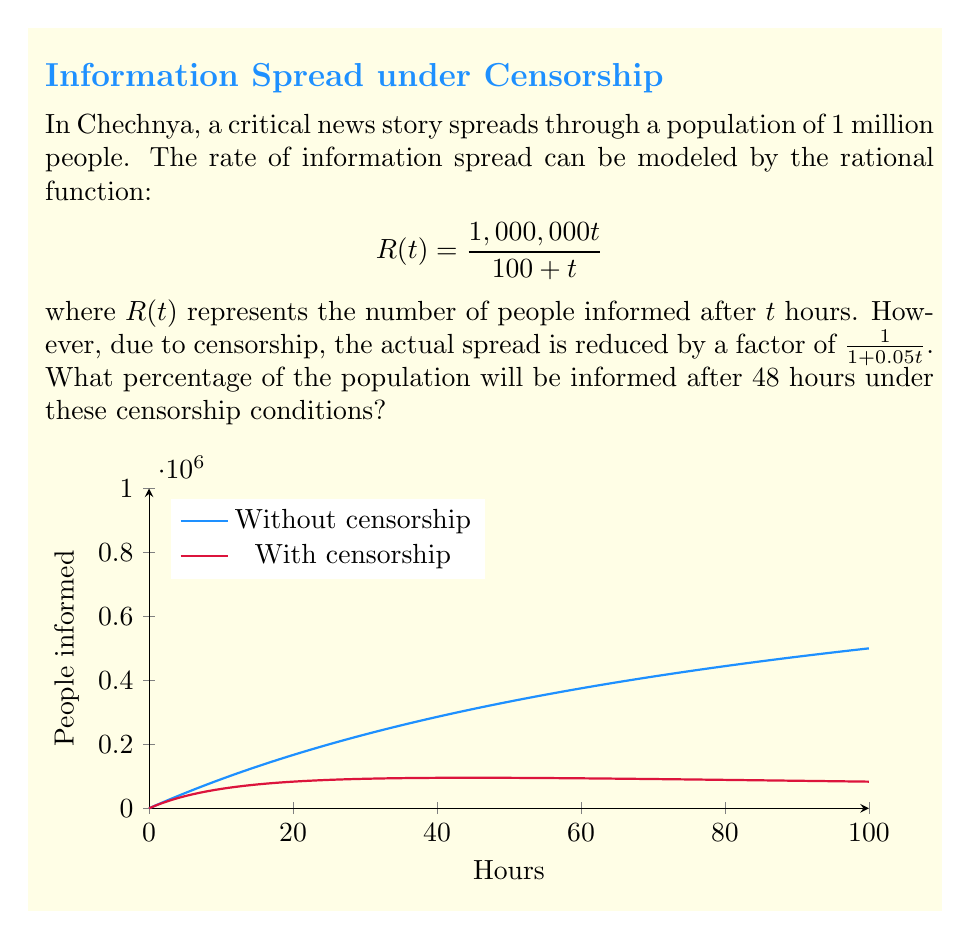Show me your answer to this math problem. Let's approach this step-by-step:

1) First, we need to modify our original function to account for censorship. The new function will be:

   $$R_c(t) = \frac{1,000,000t}{100 + t} \cdot \frac{1}{1+0.05t}$$

2) Simplify this function:

   $$R_c(t) = \frac{1,000,000t}{(100 + t)(1+0.05t)}$$

3) Now, we need to evaluate this function at t = 48:

   $$R_c(48) = \frac{1,000,000(48)}{(100 + 48)(1+0.05(48))}$$

4) Let's calculate step by step:

   $$R_c(48) = \frac{48,000,000}{(148)(3.4)}$$
   
   $$R_c(48) = \frac{48,000,000}{503.2}$$
   
   $$R_c(48) = 95,389.71$$ (rounded to 2 decimal places)

5) To find the percentage, we divide by the total population and multiply by 100:

   $$\text{Percentage} = \frac{95,389.71}{1,000,000} \times 100 = 9.54\%$$

Therefore, approximately 9.54% of the population will be informed after 48 hours under these censorship conditions.
Answer: 9.54% 